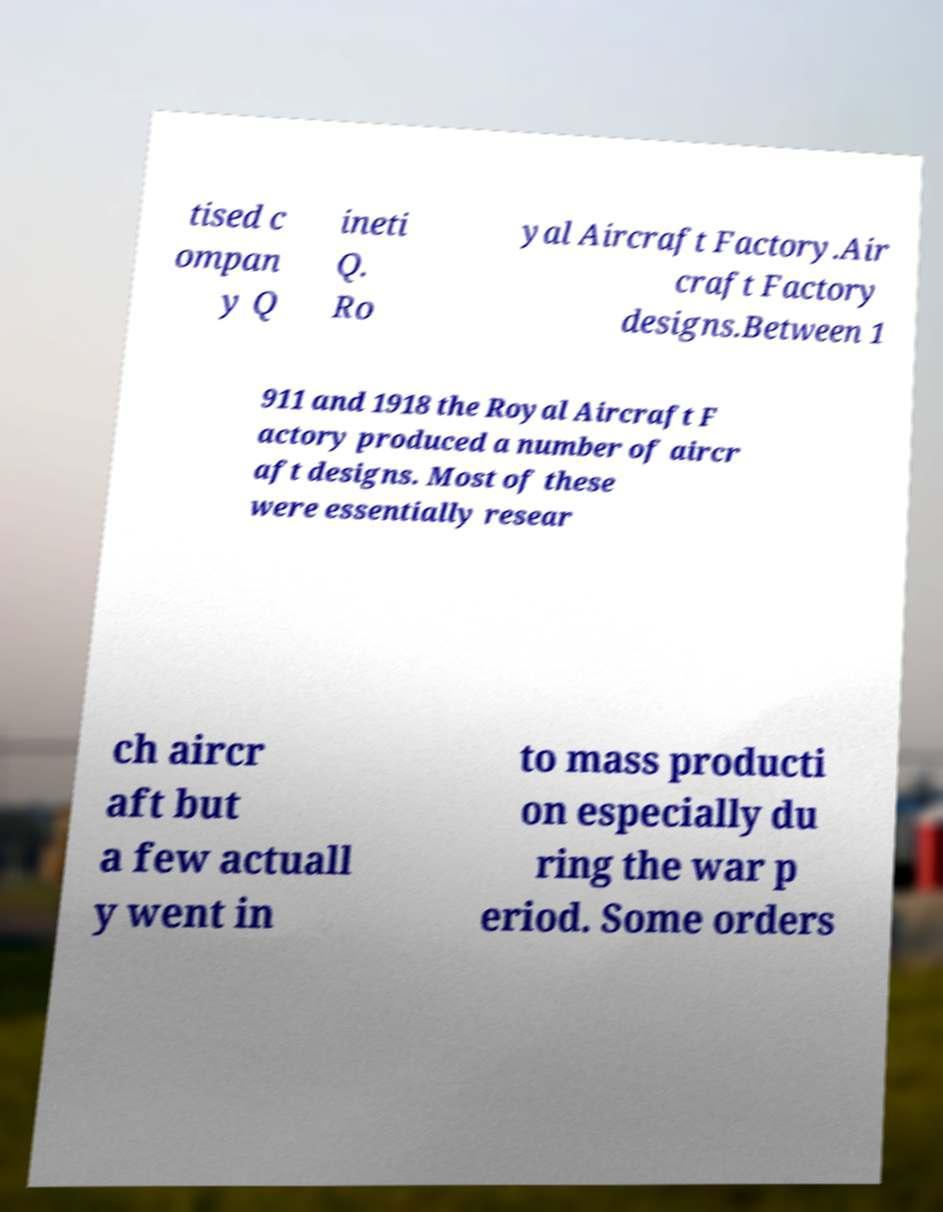Could you assist in decoding the text presented in this image and type it out clearly? tised c ompan y Q ineti Q. Ro yal Aircraft Factory.Air craft Factory designs.Between 1 911 and 1918 the Royal Aircraft F actory produced a number of aircr aft designs. Most of these were essentially resear ch aircr aft but a few actuall y went in to mass producti on especially du ring the war p eriod. Some orders 